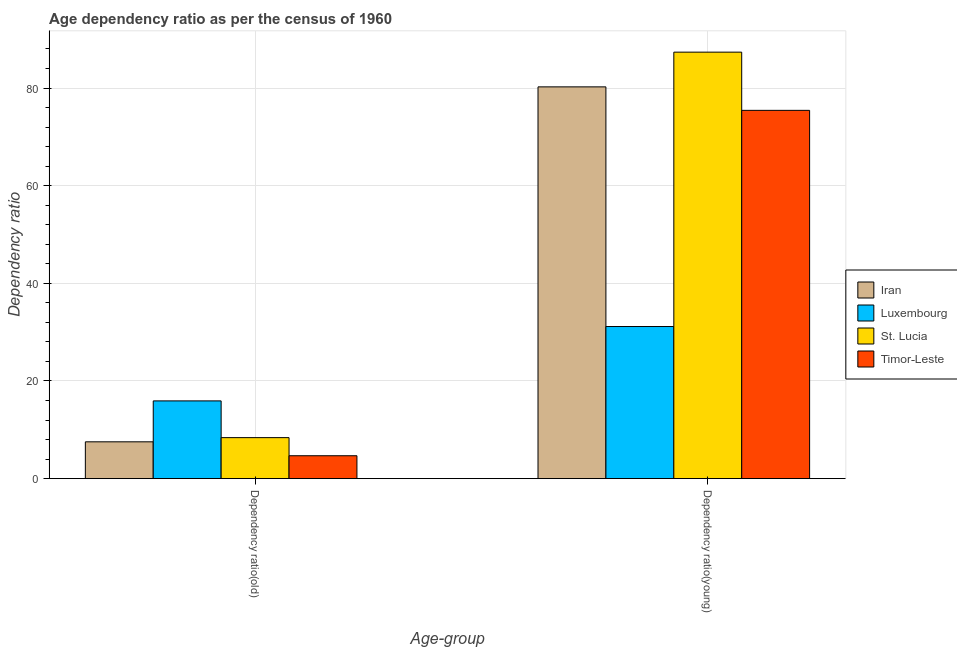How many groups of bars are there?
Provide a short and direct response. 2. Are the number of bars per tick equal to the number of legend labels?
Give a very brief answer. Yes. How many bars are there on the 2nd tick from the left?
Your answer should be compact. 4. What is the label of the 1st group of bars from the left?
Provide a short and direct response. Dependency ratio(old). What is the age dependency ratio(old) in Iran?
Your answer should be compact. 7.54. Across all countries, what is the maximum age dependency ratio(young)?
Provide a short and direct response. 87.35. Across all countries, what is the minimum age dependency ratio(old)?
Provide a succinct answer. 4.68. In which country was the age dependency ratio(young) maximum?
Offer a terse response. St. Lucia. In which country was the age dependency ratio(young) minimum?
Provide a succinct answer. Luxembourg. What is the total age dependency ratio(old) in the graph?
Make the answer very short. 36.53. What is the difference between the age dependency ratio(young) in Timor-Leste and that in Iran?
Your answer should be very brief. -4.81. What is the difference between the age dependency ratio(old) in Iran and the age dependency ratio(young) in Timor-Leste?
Offer a terse response. -67.89. What is the average age dependency ratio(young) per country?
Offer a very short reply. 68.54. What is the difference between the age dependency ratio(young) and age dependency ratio(old) in Timor-Leste?
Your response must be concise. 70.75. In how many countries, is the age dependency ratio(old) greater than 64 ?
Your answer should be compact. 0. What is the ratio of the age dependency ratio(young) in Iran to that in Timor-Leste?
Your answer should be very brief. 1.06. Is the age dependency ratio(old) in Timor-Leste less than that in Iran?
Your response must be concise. Yes. What does the 1st bar from the left in Dependency ratio(old) represents?
Provide a short and direct response. Iran. What does the 2nd bar from the right in Dependency ratio(old) represents?
Provide a short and direct response. St. Lucia. Are all the bars in the graph horizontal?
Provide a succinct answer. No. What is the difference between two consecutive major ticks on the Y-axis?
Ensure brevity in your answer.  20. Are the values on the major ticks of Y-axis written in scientific E-notation?
Provide a succinct answer. No. Does the graph contain any zero values?
Ensure brevity in your answer.  No. Does the graph contain grids?
Your answer should be very brief. Yes. How are the legend labels stacked?
Offer a very short reply. Vertical. What is the title of the graph?
Ensure brevity in your answer.  Age dependency ratio as per the census of 1960. Does "Central Europe" appear as one of the legend labels in the graph?
Provide a short and direct response. No. What is the label or title of the X-axis?
Offer a terse response. Age-group. What is the label or title of the Y-axis?
Your answer should be very brief. Dependency ratio. What is the Dependency ratio in Iran in Dependency ratio(old)?
Keep it short and to the point. 7.54. What is the Dependency ratio of Luxembourg in Dependency ratio(old)?
Offer a very short reply. 15.92. What is the Dependency ratio in St. Lucia in Dependency ratio(old)?
Ensure brevity in your answer.  8.39. What is the Dependency ratio of Timor-Leste in Dependency ratio(old)?
Offer a terse response. 4.68. What is the Dependency ratio in Iran in Dependency ratio(young)?
Provide a succinct answer. 80.24. What is the Dependency ratio in Luxembourg in Dependency ratio(young)?
Offer a very short reply. 31.15. What is the Dependency ratio of St. Lucia in Dependency ratio(young)?
Your answer should be very brief. 87.35. What is the Dependency ratio in Timor-Leste in Dependency ratio(young)?
Your answer should be very brief. 75.43. Across all Age-group, what is the maximum Dependency ratio in Iran?
Your answer should be compact. 80.24. Across all Age-group, what is the maximum Dependency ratio of Luxembourg?
Provide a succinct answer. 31.15. Across all Age-group, what is the maximum Dependency ratio of St. Lucia?
Your answer should be very brief. 87.35. Across all Age-group, what is the maximum Dependency ratio in Timor-Leste?
Your answer should be compact. 75.43. Across all Age-group, what is the minimum Dependency ratio of Iran?
Your answer should be compact. 7.54. Across all Age-group, what is the minimum Dependency ratio in Luxembourg?
Your answer should be compact. 15.92. Across all Age-group, what is the minimum Dependency ratio of St. Lucia?
Give a very brief answer. 8.39. Across all Age-group, what is the minimum Dependency ratio in Timor-Leste?
Give a very brief answer. 4.68. What is the total Dependency ratio in Iran in the graph?
Keep it short and to the point. 87.78. What is the total Dependency ratio in Luxembourg in the graph?
Offer a terse response. 47.07. What is the total Dependency ratio in St. Lucia in the graph?
Make the answer very short. 95.75. What is the total Dependency ratio in Timor-Leste in the graph?
Provide a succinct answer. 80.12. What is the difference between the Dependency ratio of Iran in Dependency ratio(old) and that in Dependency ratio(young)?
Make the answer very short. -72.7. What is the difference between the Dependency ratio in Luxembourg in Dependency ratio(old) and that in Dependency ratio(young)?
Offer a terse response. -15.23. What is the difference between the Dependency ratio of St. Lucia in Dependency ratio(old) and that in Dependency ratio(young)?
Offer a very short reply. -78.96. What is the difference between the Dependency ratio of Timor-Leste in Dependency ratio(old) and that in Dependency ratio(young)?
Keep it short and to the point. -70.75. What is the difference between the Dependency ratio in Iran in Dependency ratio(old) and the Dependency ratio in Luxembourg in Dependency ratio(young)?
Give a very brief answer. -23.62. What is the difference between the Dependency ratio of Iran in Dependency ratio(old) and the Dependency ratio of St. Lucia in Dependency ratio(young)?
Your answer should be compact. -79.82. What is the difference between the Dependency ratio in Iran in Dependency ratio(old) and the Dependency ratio in Timor-Leste in Dependency ratio(young)?
Your answer should be compact. -67.89. What is the difference between the Dependency ratio in Luxembourg in Dependency ratio(old) and the Dependency ratio in St. Lucia in Dependency ratio(young)?
Offer a very short reply. -71.43. What is the difference between the Dependency ratio in Luxembourg in Dependency ratio(old) and the Dependency ratio in Timor-Leste in Dependency ratio(young)?
Ensure brevity in your answer.  -59.51. What is the difference between the Dependency ratio in St. Lucia in Dependency ratio(old) and the Dependency ratio in Timor-Leste in Dependency ratio(young)?
Ensure brevity in your answer.  -67.04. What is the average Dependency ratio in Iran per Age-group?
Your response must be concise. 43.89. What is the average Dependency ratio of Luxembourg per Age-group?
Ensure brevity in your answer.  23.54. What is the average Dependency ratio in St. Lucia per Age-group?
Offer a terse response. 47.87. What is the average Dependency ratio in Timor-Leste per Age-group?
Ensure brevity in your answer.  40.06. What is the difference between the Dependency ratio in Iran and Dependency ratio in Luxembourg in Dependency ratio(old)?
Give a very brief answer. -8.38. What is the difference between the Dependency ratio of Iran and Dependency ratio of St. Lucia in Dependency ratio(old)?
Keep it short and to the point. -0.86. What is the difference between the Dependency ratio of Iran and Dependency ratio of Timor-Leste in Dependency ratio(old)?
Give a very brief answer. 2.85. What is the difference between the Dependency ratio of Luxembourg and Dependency ratio of St. Lucia in Dependency ratio(old)?
Provide a succinct answer. 7.53. What is the difference between the Dependency ratio of Luxembourg and Dependency ratio of Timor-Leste in Dependency ratio(old)?
Make the answer very short. 11.23. What is the difference between the Dependency ratio in St. Lucia and Dependency ratio in Timor-Leste in Dependency ratio(old)?
Your answer should be very brief. 3.71. What is the difference between the Dependency ratio in Iran and Dependency ratio in Luxembourg in Dependency ratio(young)?
Your answer should be very brief. 49.09. What is the difference between the Dependency ratio of Iran and Dependency ratio of St. Lucia in Dependency ratio(young)?
Offer a terse response. -7.11. What is the difference between the Dependency ratio of Iran and Dependency ratio of Timor-Leste in Dependency ratio(young)?
Ensure brevity in your answer.  4.81. What is the difference between the Dependency ratio of Luxembourg and Dependency ratio of St. Lucia in Dependency ratio(young)?
Ensure brevity in your answer.  -56.2. What is the difference between the Dependency ratio of Luxembourg and Dependency ratio of Timor-Leste in Dependency ratio(young)?
Keep it short and to the point. -44.28. What is the difference between the Dependency ratio in St. Lucia and Dependency ratio in Timor-Leste in Dependency ratio(young)?
Your answer should be very brief. 11.92. What is the ratio of the Dependency ratio in Iran in Dependency ratio(old) to that in Dependency ratio(young)?
Your response must be concise. 0.09. What is the ratio of the Dependency ratio in Luxembourg in Dependency ratio(old) to that in Dependency ratio(young)?
Your answer should be compact. 0.51. What is the ratio of the Dependency ratio of St. Lucia in Dependency ratio(old) to that in Dependency ratio(young)?
Your answer should be compact. 0.1. What is the ratio of the Dependency ratio of Timor-Leste in Dependency ratio(old) to that in Dependency ratio(young)?
Provide a short and direct response. 0.06. What is the difference between the highest and the second highest Dependency ratio in Iran?
Ensure brevity in your answer.  72.7. What is the difference between the highest and the second highest Dependency ratio of Luxembourg?
Give a very brief answer. 15.23. What is the difference between the highest and the second highest Dependency ratio in St. Lucia?
Provide a short and direct response. 78.96. What is the difference between the highest and the second highest Dependency ratio in Timor-Leste?
Provide a short and direct response. 70.75. What is the difference between the highest and the lowest Dependency ratio in Iran?
Ensure brevity in your answer.  72.7. What is the difference between the highest and the lowest Dependency ratio of Luxembourg?
Offer a terse response. 15.23. What is the difference between the highest and the lowest Dependency ratio of St. Lucia?
Keep it short and to the point. 78.96. What is the difference between the highest and the lowest Dependency ratio of Timor-Leste?
Keep it short and to the point. 70.75. 